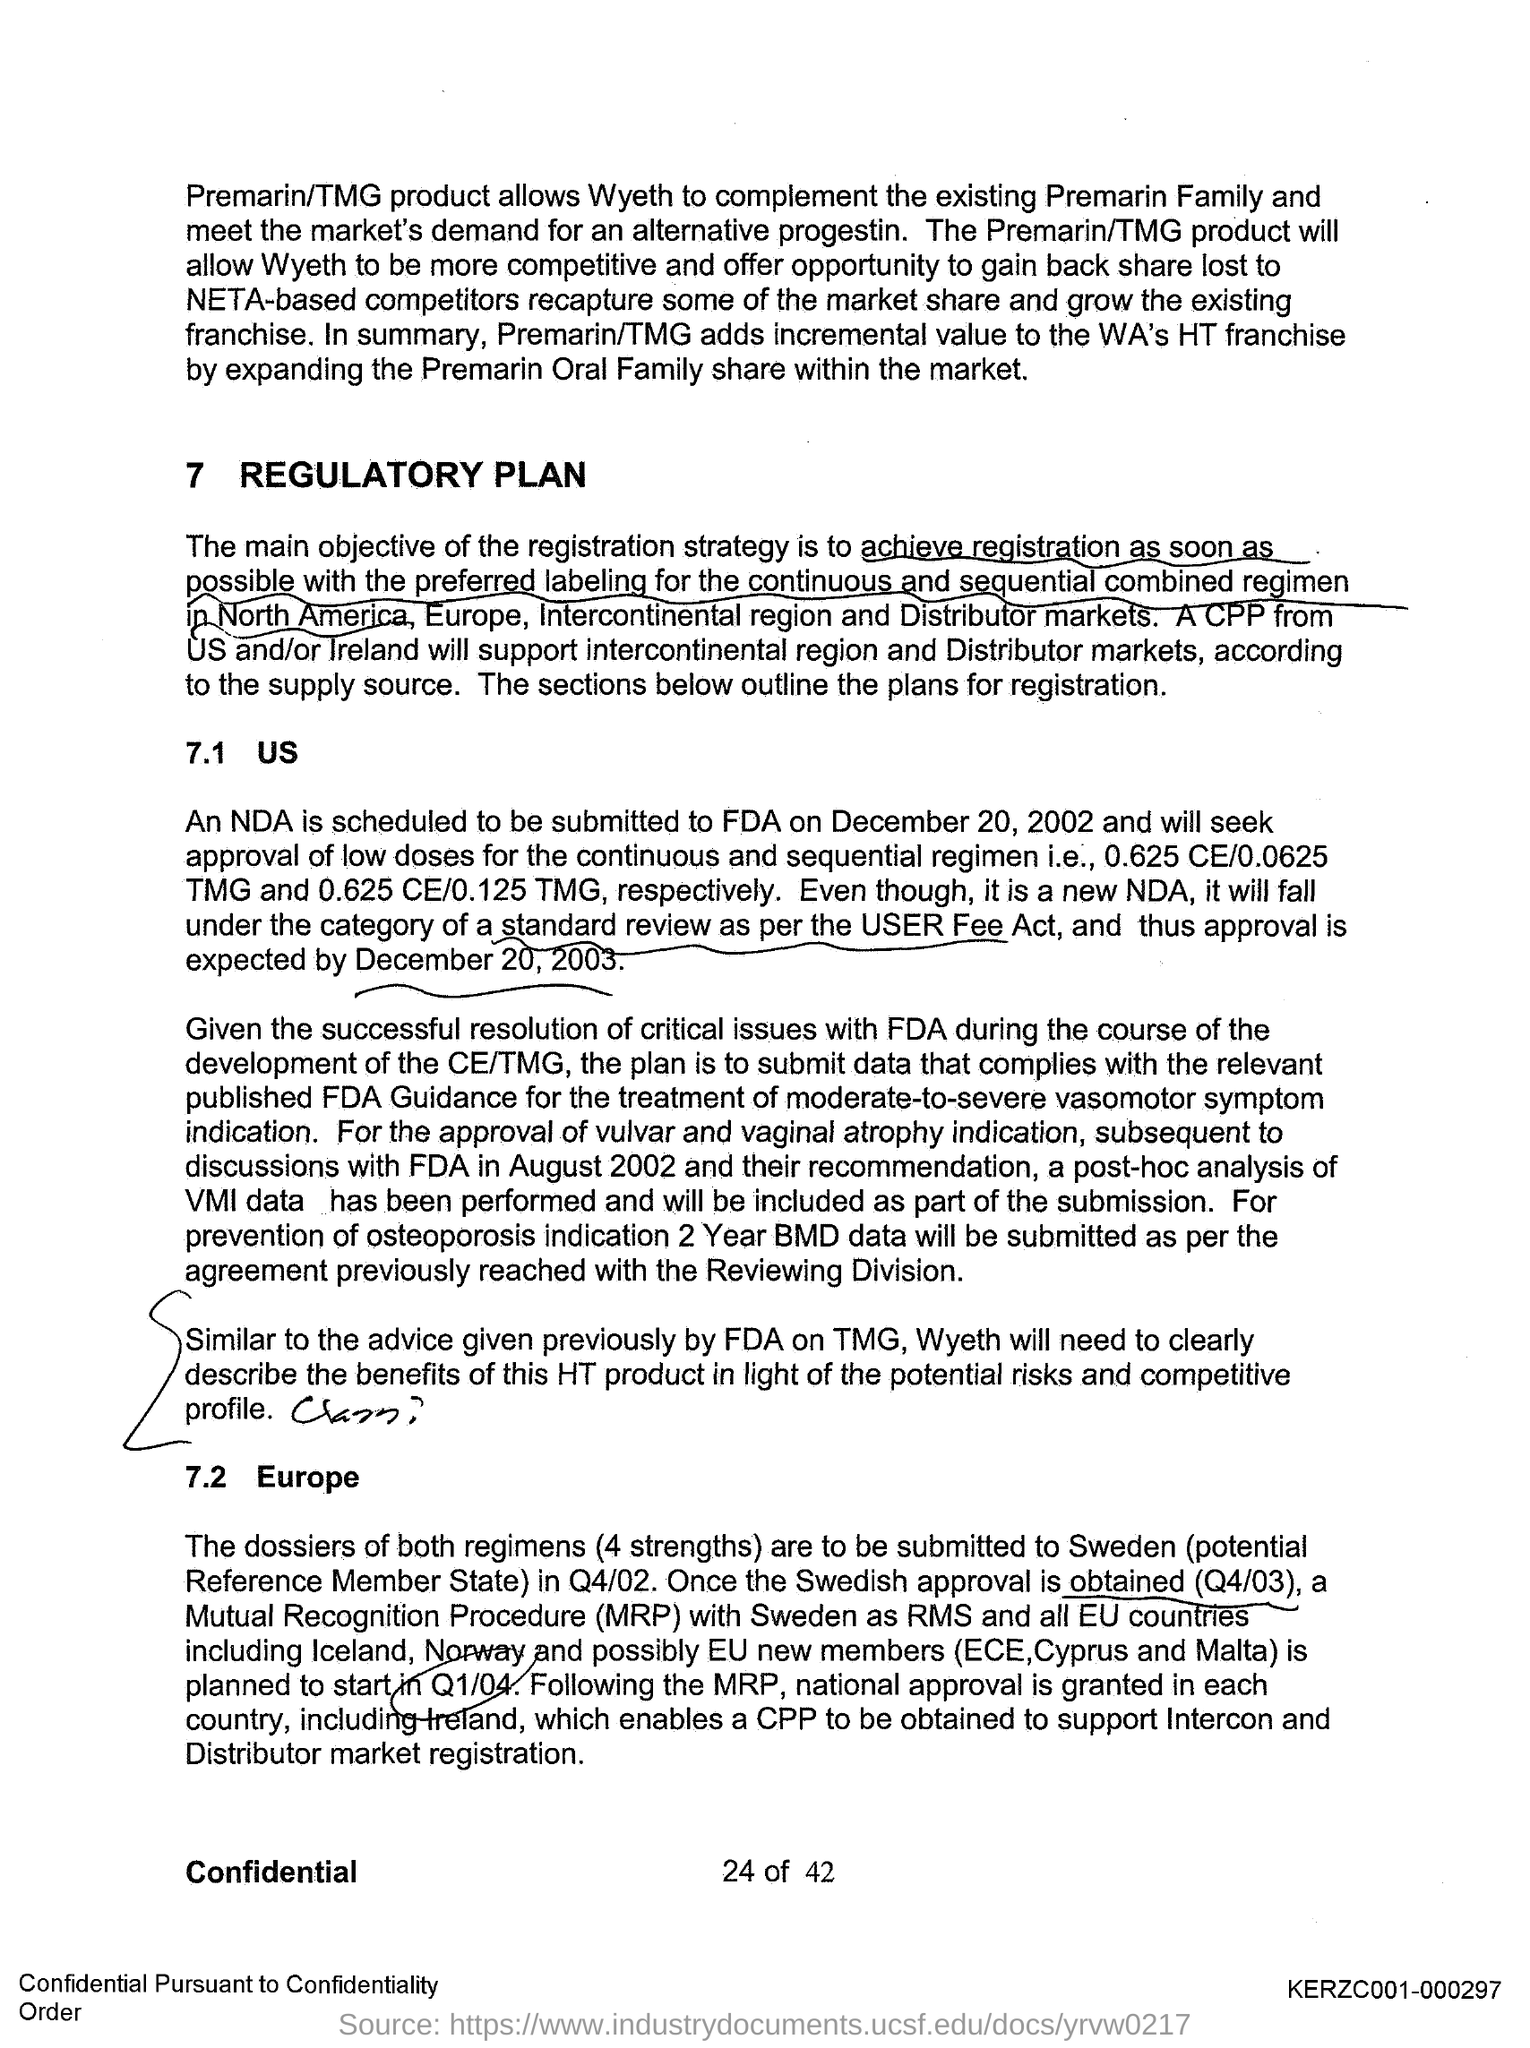What allows Wyeth to complement the existing Premarin Family?
Make the answer very short. The premarin/tmg product. What allows Wyeth to meet the market's demand for an alternate progestin?
Your answer should be compact. Premarin/tmg product. What is the main objective of the registration strategy?
Provide a short and direct response. To achieve registration as soon as possible with the preferred labelling for the continuous and sequential combined regimen in North America, Europe, Intercontinental region and Distributor markets. Who will support intercontinental region and Distributor markets?
Your response must be concise. A CPP from US and/or Ireland. When is the NDA scheduled to be submitted?
Provide a short and direct response. December 20, 2002. When is the approval of the nda expected?
Provide a succinct answer. December 20, 2003. When is the NDA submission to FDA scheduled at?
Provide a short and direct response. December 20,2002. What is done for the approval of vulvar and vaginal atrophy indication?
Provide a short and direct response. A post-hoc analysis of vmi data has been performed and will be included as part of the submission. 